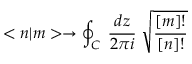<formula> <loc_0><loc_0><loc_500><loc_500>< n | m > \rightarrow \oint _ { C } \, \frac { d z } { 2 \pi i } \, \sqrt { \frac { [ m ] ! } { [ n ] ! } }</formula> 